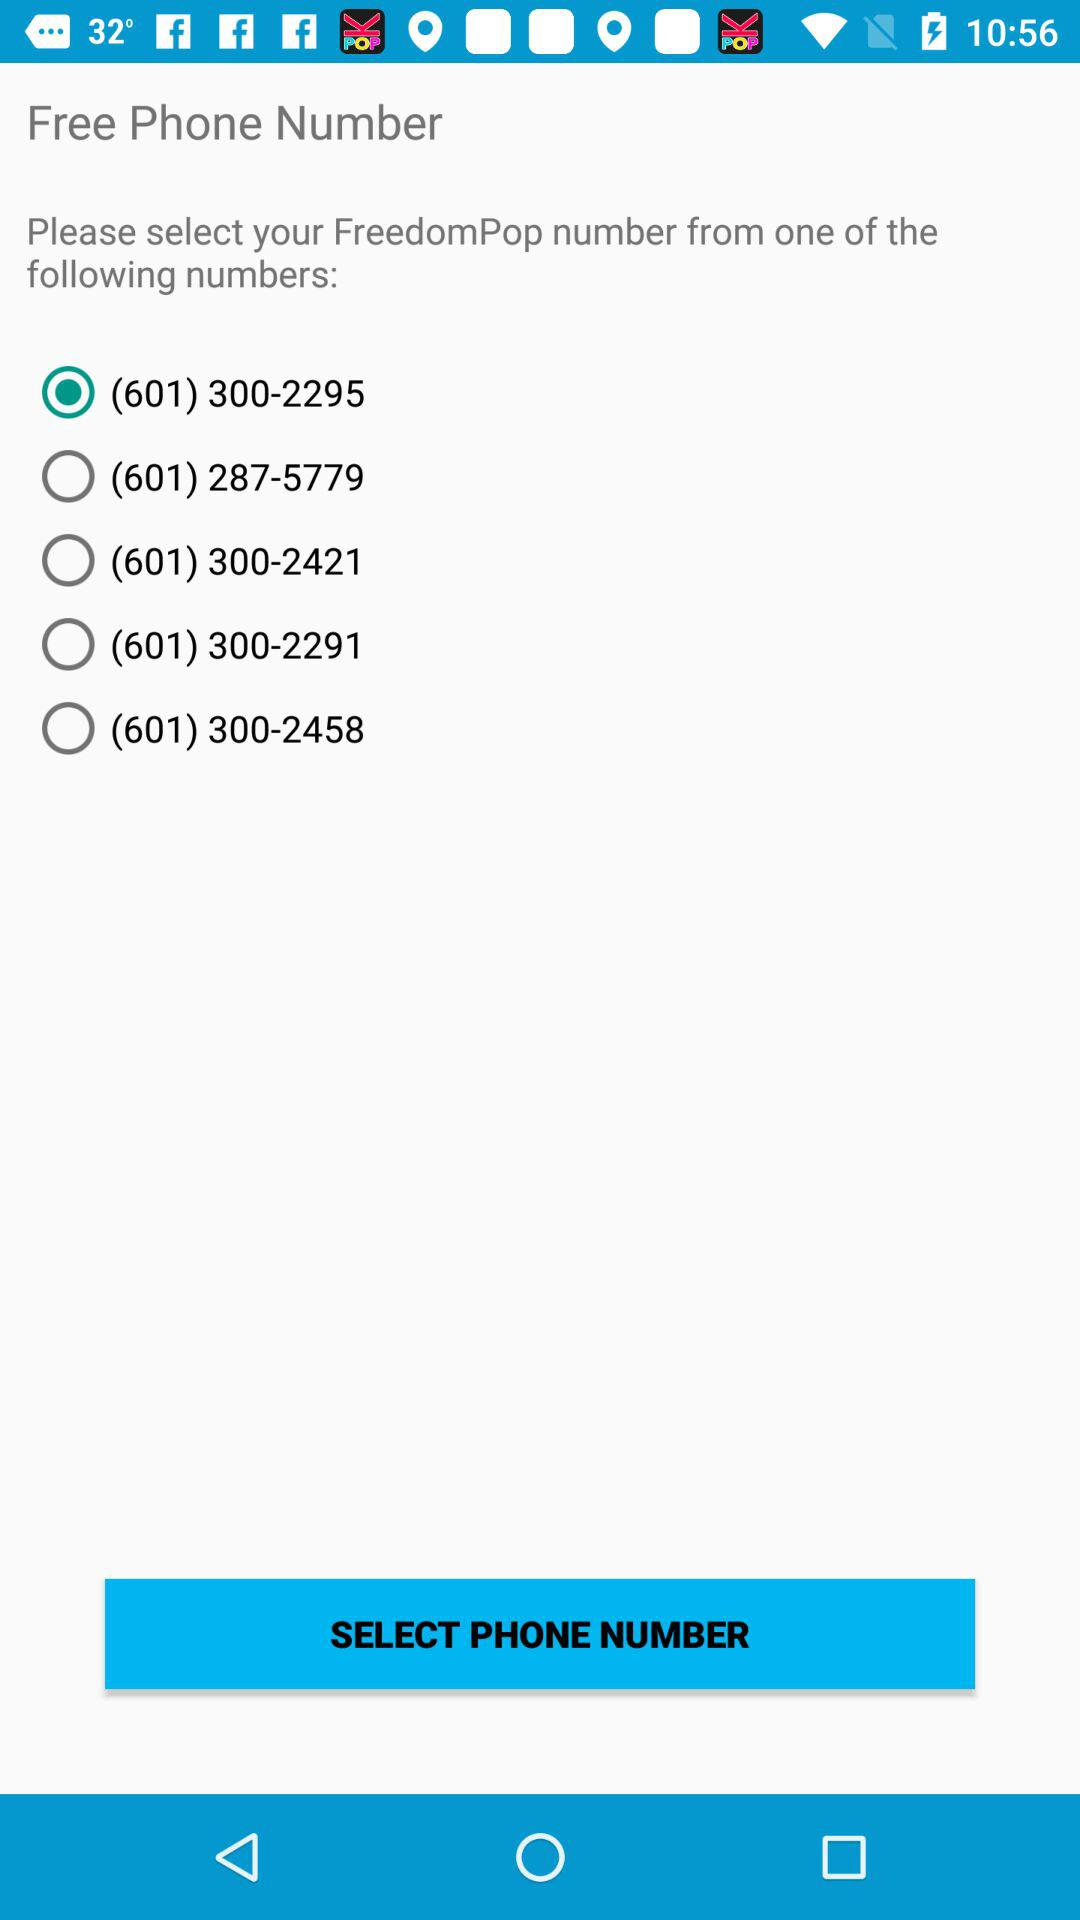How many phone numbers are available for selection?
Answer the question using a single word or phrase. 5 